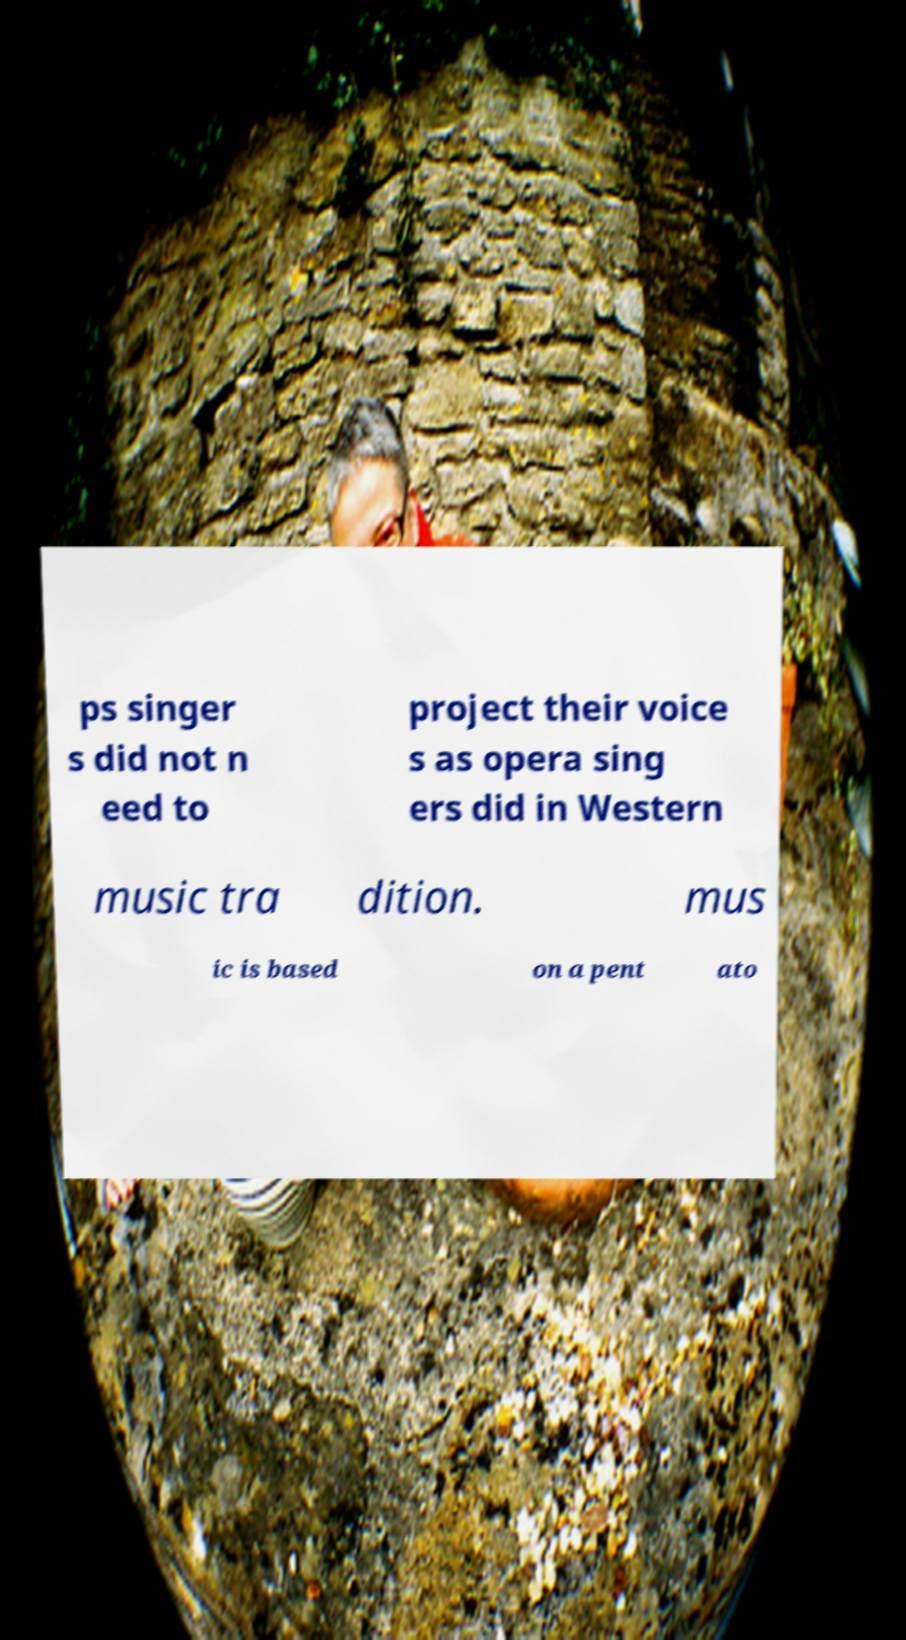What messages or text are displayed in this image? I need them in a readable, typed format. ps singer s did not n eed to project their voice s as opera sing ers did in Western music tra dition. mus ic is based on a pent ato 